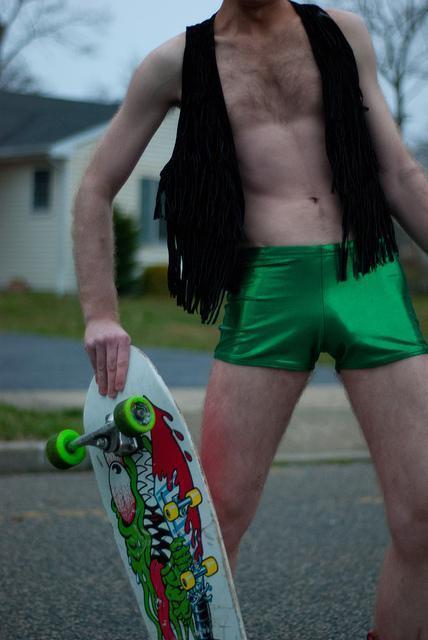How many cars are driving in the opposite direction of the street car?
Give a very brief answer. 0. 